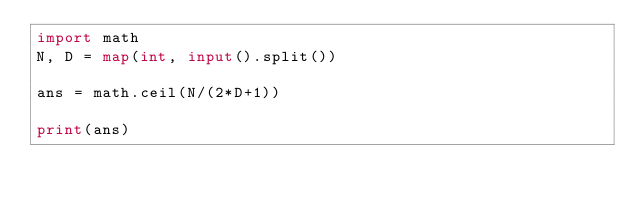<code> <loc_0><loc_0><loc_500><loc_500><_Python_>import math
N, D = map(int, input().split())

ans = math.ceil(N/(2*D+1))

print(ans)</code> 